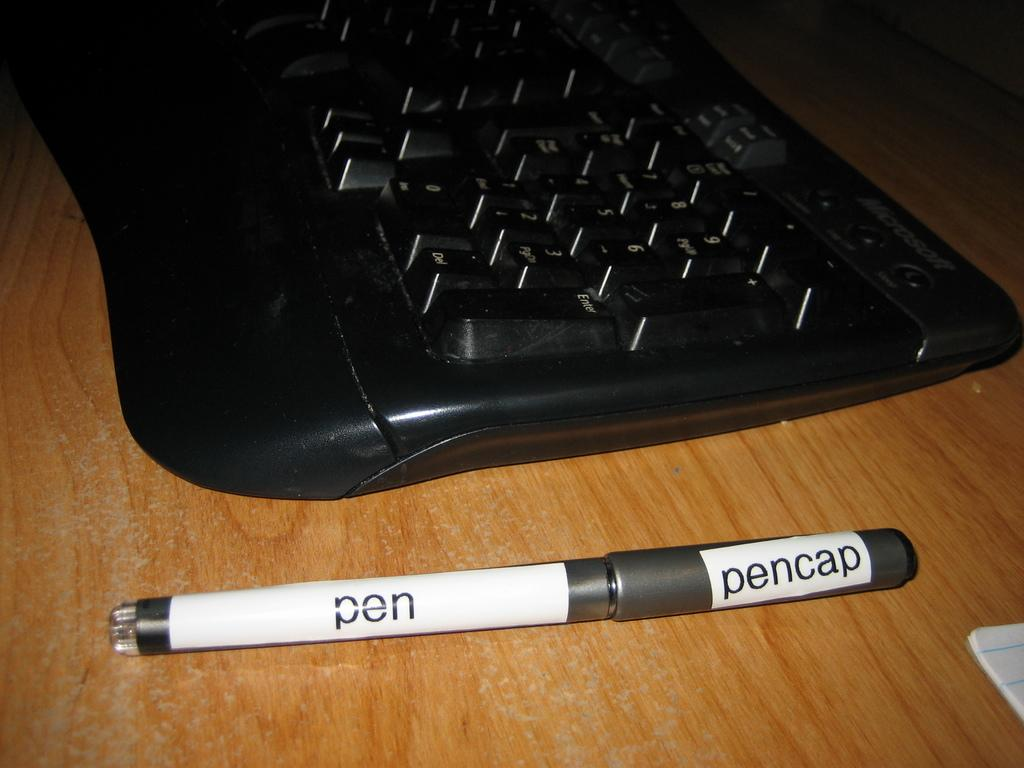<image>
Share a concise interpretation of the image provided. silver pen that has labeled sections pen and pencap on it next to a black keyboard on a wooden surface 